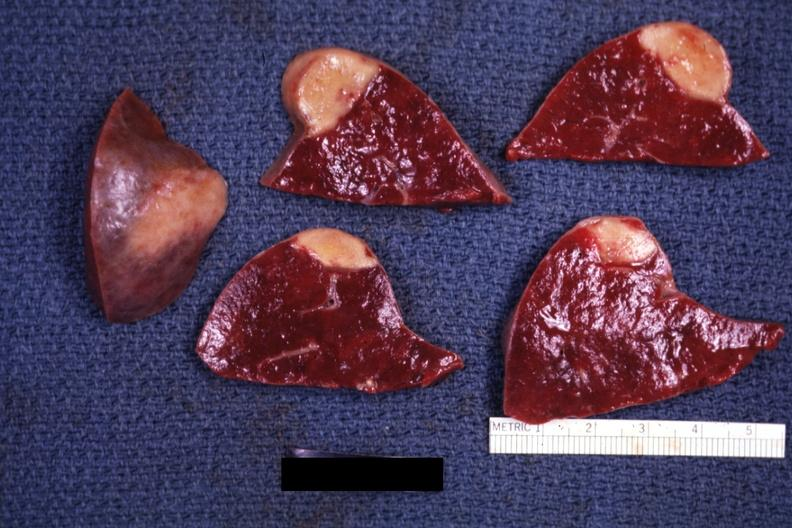s spleen present?
Answer the question using a single word or phrase. Yes 